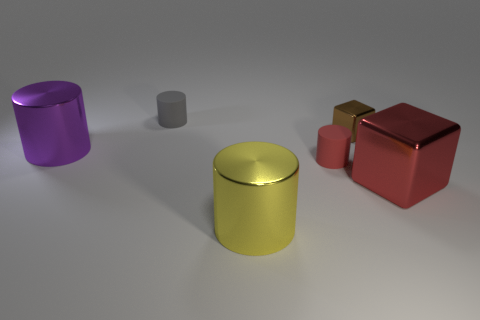Is the number of large shiny cubes that are left of the tiny cube less than the number of yellow metallic cylinders that are on the left side of the big yellow metallic cylinder?
Offer a terse response. No. There is a small matte thing that is to the left of the yellow metallic cylinder; does it have the same color as the metallic cube to the right of the tiny metal thing?
Your answer should be compact. No. There is a small object that is on the left side of the tiny shiny thing and behind the big purple cylinder; what material is it?
Offer a terse response. Rubber. Are there any cylinders?
Provide a short and direct response. Yes. There is a brown thing that is made of the same material as the large yellow thing; what shape is it?
Offer a very short reply. Cube. There is a tiny red rubber object; is its shape the same as the small thing behind the brown metallic cube?
Offer a terse response. Yes. The block that is in front of the metallic cube behind the red block is made of what material?
Make the answer very short. Metal. What number of other things are there of the same shape as the big yellow object?
Provide a short and direct response. 3. There is a big object that is to the left of the small gray object; does it have the same shape as the yellow metallic thing in front of the tiny metallic object?
Offer a terse response. Yes. Is there anything else that is made of the same material as the tiny gray cylinder?
Keep it short and to the point. Yes. 